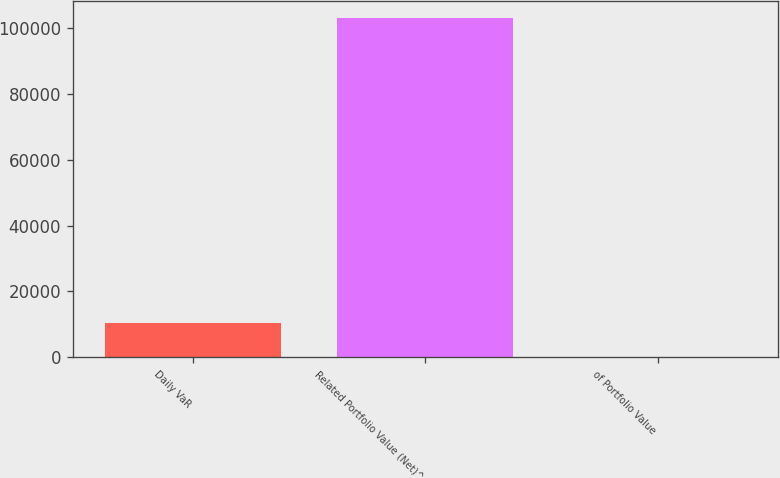Convert chart. <chart><loc_0><loc_0><loc_500><loc_500><bar_chart><fcel>Daily VaR<fcel>Related Portfolio Value (Net)^<fcel>of Portfolio Value<nl><fcel>10305.2<fcel>103047<fcel>0.57<nl></chart> 